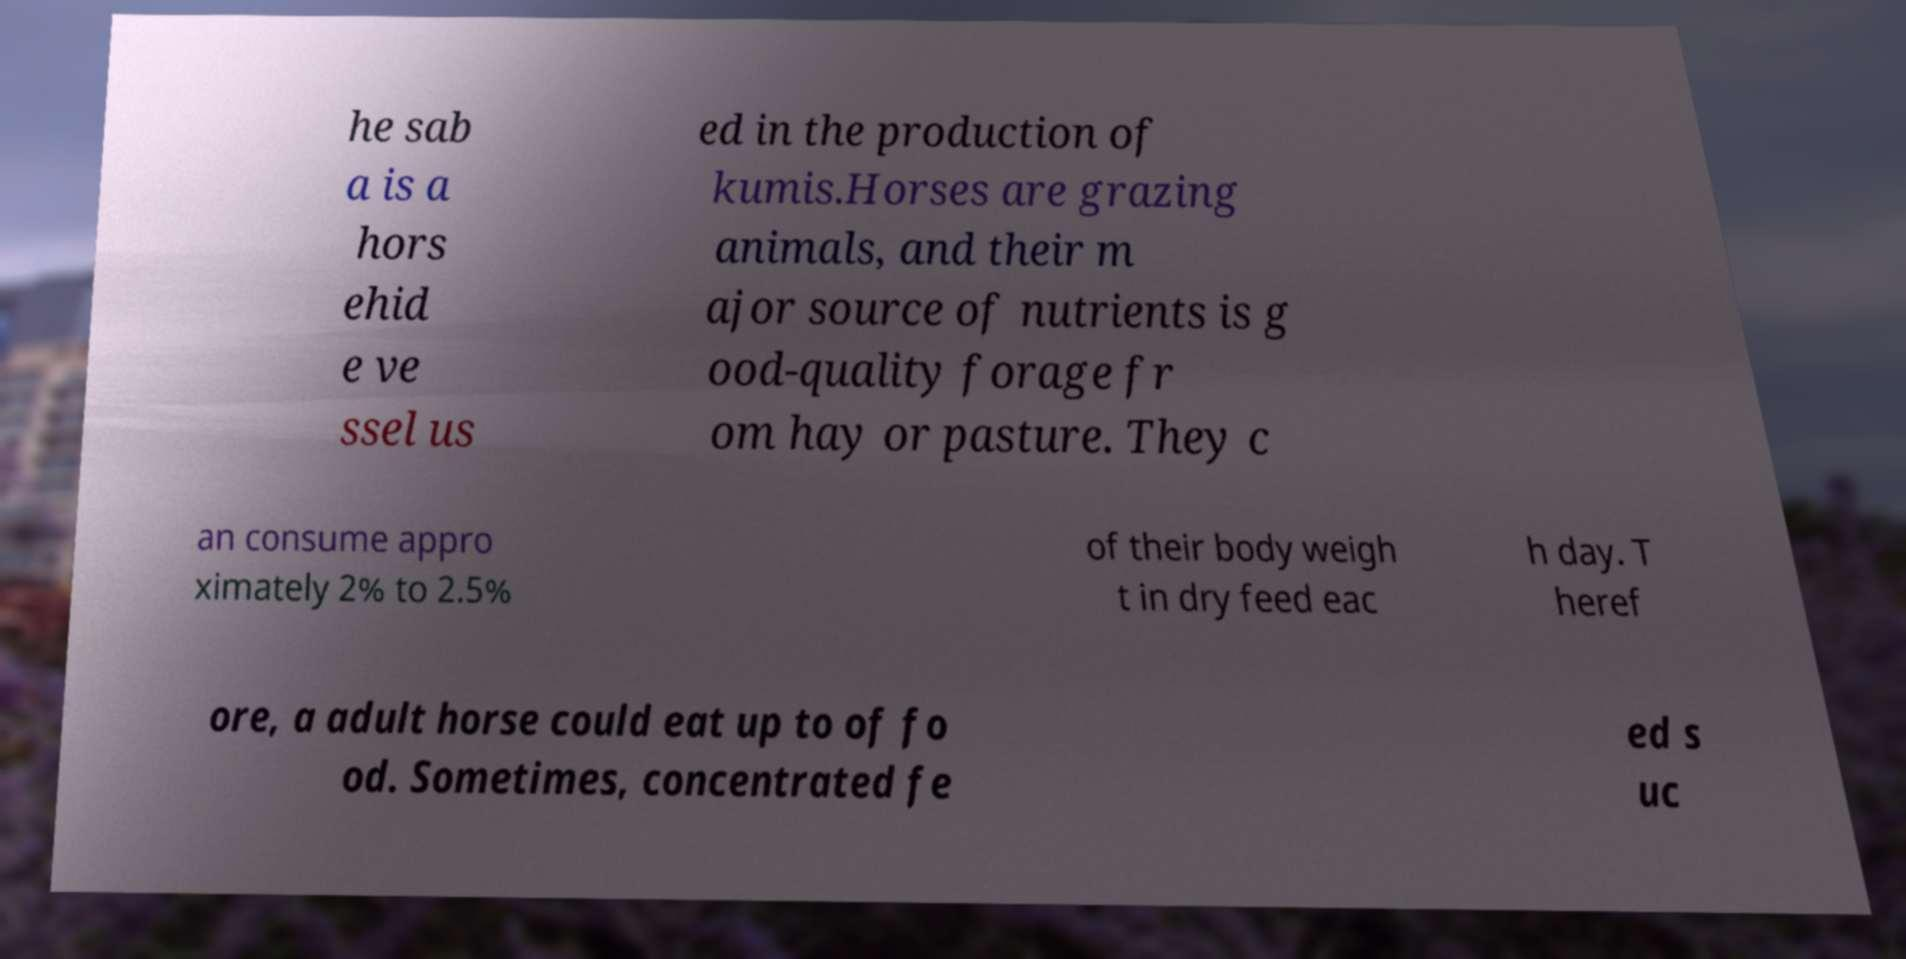Can you accurately transcribe the text from the provided image for me? he sab a is a hors ehid e ve ssel us ed in the production of kumis.Horses are grazing animals, and their m ajor source of nutrients is g ood-quality forage fr om hay or pasture. They c an consume appro ximately 2% to 2.5% of their body weigh t in dry feed eac h day. T heref ore, a adult horse could eat up to of fo od. Sometimes, concentrated fe ed s uc 